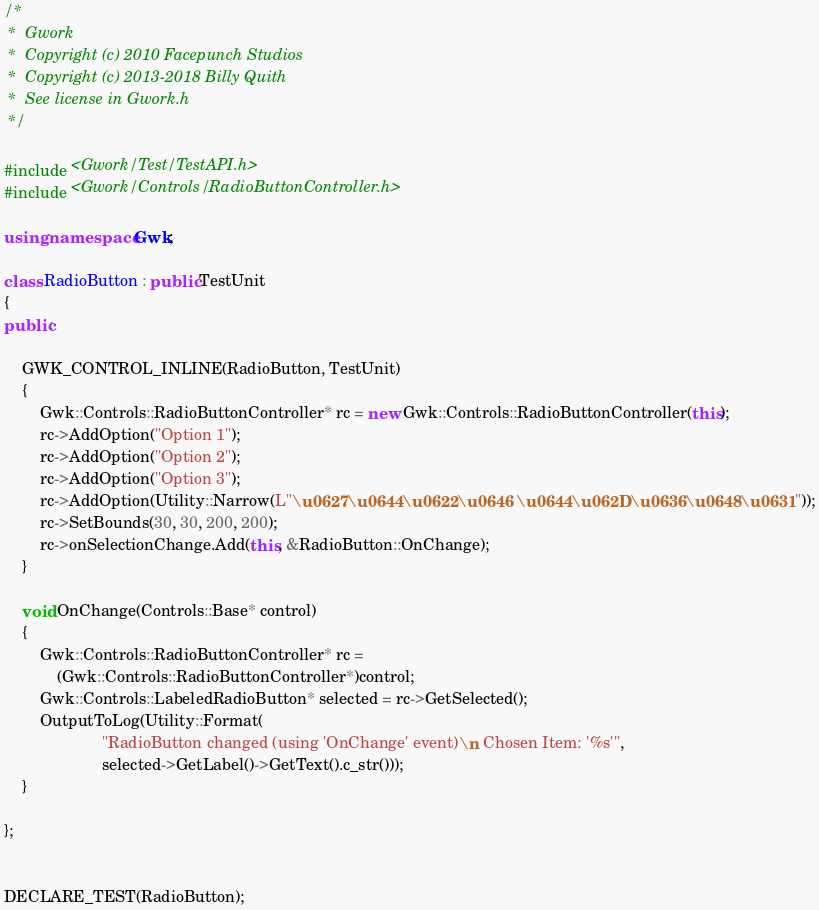Convert code to text. <code><loc_0><loc_0><loc_500><loc_500><_C++_>/*
 *  Gwork
 *  Copyright (c) 2010 Facepunch Studios
 *  Copyright (c) 2013-2018 Billy Quith
 *  See license in Gwork.h
 */

#include <Gwork/Test/TestAPI.h>
#include <Gwork/Controls/RadioButtonController.h>

using namespace Gwk;

class RadioButton : public TestUnit
{
public:

    GWK_CONTROL_INLINE(RadioButton, TestUnit)
    {
        Gwk::Controls::RadioButtonController* rc = new Gwk::Controls::RadioButtonController(this);
        rc->AddOption("Option 1");
        rc->AddOption("Option 2");
        rc->AddOption("Option 3");
        rc->AddOption(Utility::Narrow(L"\u0627\u0644\u0622\u0646 \u0644\u062D\u0636\u0648\u0631"));
        rc->SetBounds(30, 30, 200, 200);
        rc->onSelectionChange.Add(this, &RadioButton::OnChange);
    }

    void OnChange(Controls::Base* control)
    {
        Gwk::Controls::RadioButtonController* rc =
            (Gwk::Controls::RadioButtonController*)control;
        Gwk::Controls::LabeledRadioButton* selected = rc->GetSelected();
        OutputToLog(Utility::Format(
                      "RadioButton changed (using 'OnChange' event)\n Chosen Item: '%s'",
                      selected->GetLabel()->GetText().c_str()));
    }

};


DECLARE_TEST(RadioButton);
</code> 